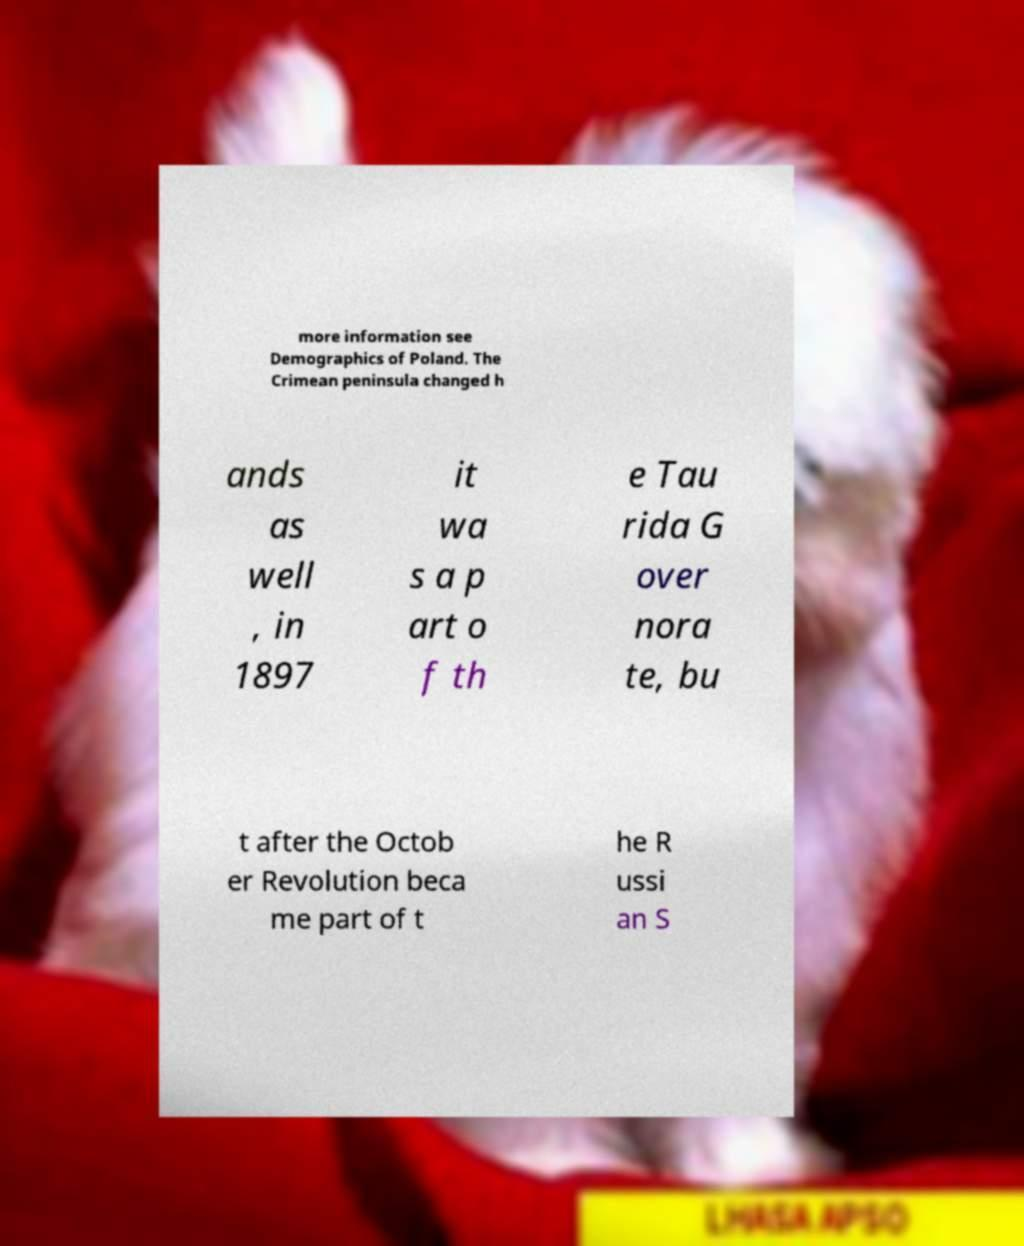Could you assist in decoding the text presented in this image and type it out clearly? more information see Demographics of Poland. The Crimean peninsula changed h ands as well , in 1897 it wa s a p art o f th e Tau rida G over nora te, bu t after the Octob er Revolution beca me part of t he R ussi an S 